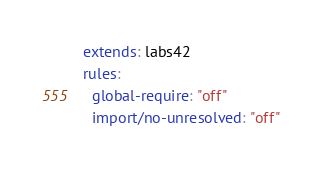<code> <loc_0><loc_0><loc_500><loc_500><_YAML_>extends: labs42
rules:
  global-require: "off"
  import/no-unresolved: "off"</code> 